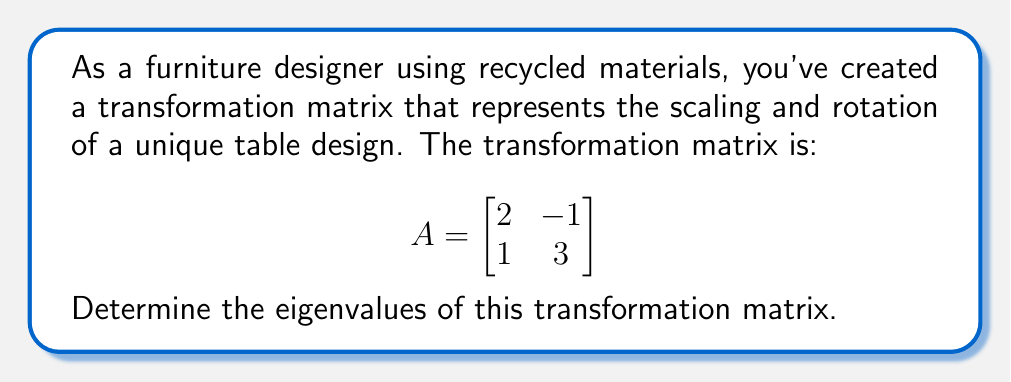Can you answer this question? To find the eigenvalues of the transformation matrix A, we follow these steps:

1) The eigenvalues λ are found by solving the characteristic equation:
   $det(A - λI) = 0$, where I is the 2x2 identity matrix.

2) Let's set up the equation:
   $$det\begin{pmatrix}
   2-λ & -1 \\
   1 & 3-λ
   \end{pmatrix} = 0$$

3) Expand the determinant:
   $(2-λ)(3-λ) - (-1)(1) = 0$

4) Simplify:
   $6 - 5λ + λ^2 + 1 = 0$
   $λ^2 - 5λ + 7 = 0$

5) This is a quadratic equation. We can solve it using the quadratic formula:
   $λ = \frac{-b \pm \sqrt{b^2 - 4ac}}{2a}$

   Where $a=1$, $b=-5$, and $c=7$

6) Plugging in these values:
   $λ = \frac{5 \pm \sqrt{25 - 28}}{2} = \frac{5 \pm \sqrt{-3}}{2}$

7) Simplify:
   $λ = \frac{5 \pm i\sqrt{3}}{2}$

Therefore, the eigenvalues are $\frac{5 + i\sqrt{3}}{2}$ and $\frac{5 - i\sqrt{3}}{2}$.
Answer: $\frac{5 \pm i\sqrt{3}}{2}$ 